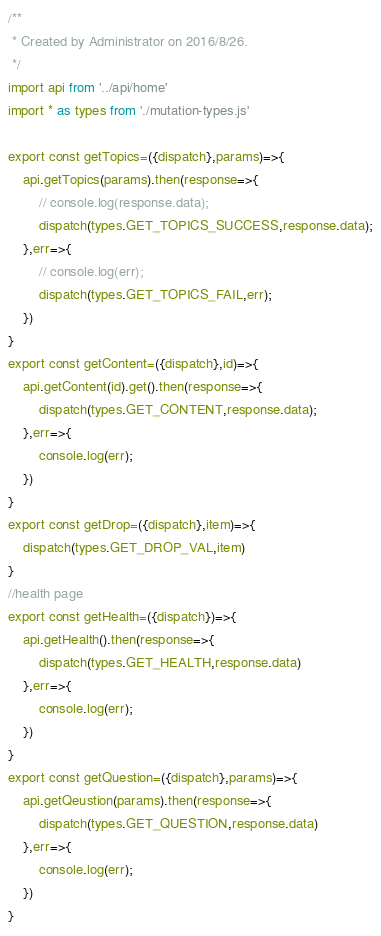Convert code to text. <code><loc_0><loc_0><loc_500><loc_500><_JavaScript_>/**
 * Created by Administrator on 2016/8/26.
 */
import api from '../api/home'
import * as types from './mutation-types.js'

export const getTopics=({dispatch},params)=>{
    api.getTopics(params).then(response=>{
        // console.log(response.data);
        dispatch(types.GET_TOPICS_SUCCESS,response.data);
    },err=>{
        // console.log(err);
        dispatch(types.GET_TOPICS_FAIL,err);
    })
}
export const getContent=({dispatch},id)=>{
    api.getContent(id).get().then(response=>{
        dispatch(types.GET_CONTENT,response.data);
    },err=>{
        console.log(err);
    })
}
export const getDrop=({dispatch},item)=>{
    dispatch(types.GET_DROP_VAL,item)
}
//health page
export const getHealth=({dispatch})=>{
    api.getHealth().then(response=>{
        dispatch(types.GET_HEALTH,response.data)
    },err=>{
        console.log(err);
    })
}
export const getQuestion=({dispatch},params)=>{
    api.getQeustion(params).then(response=>{
        dispatch(types.GET_QUESTION,response.data)
    },err=>{
        console.log(err);
    })
}

</code> 